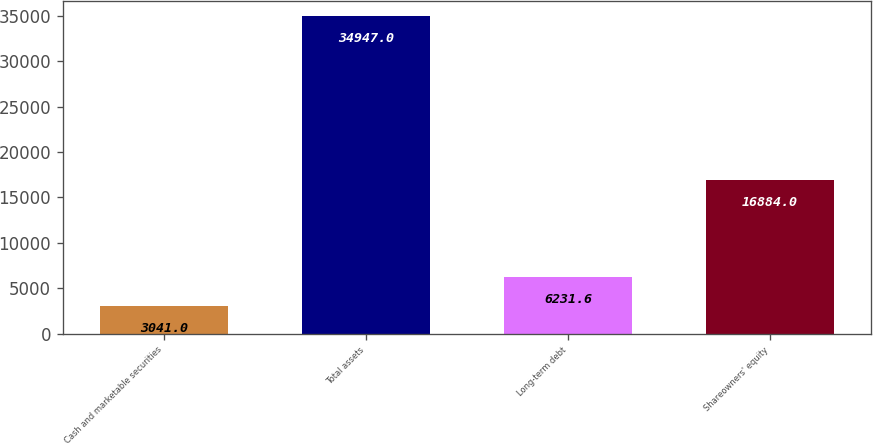<chart> <loc_0><loc_0><loc_500><loc_500><bar_chart><fcel>Cash and marketable securities<fcel>Total assets<fcel>Long-term debt<fcel>Shareowners' equity<nl><fcel>3041<fcel>34947<fcel>6231.6<fcel>16884<nl></chart> 